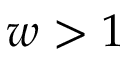<formula> <loc_0><loc_0><loc_500><loc_500>w > 1</formula> 